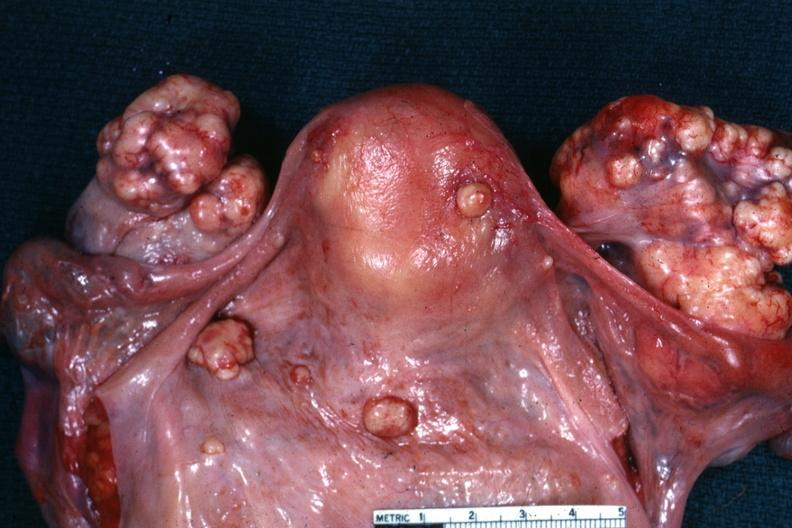s krukenberg tumor present?
Answer the question using a single word or phrase. Yes 